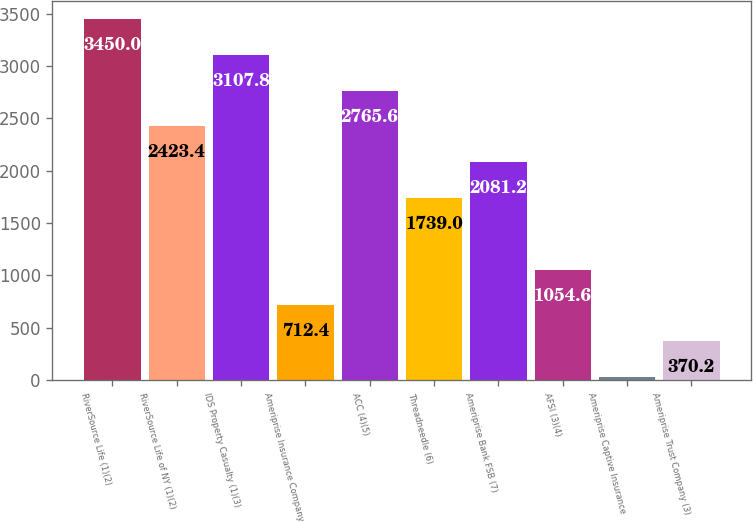<chart> <loc_0><loc_0><loc_500><loc_500><bar_chart><fcel>RiverSource Life (1)(2)<fcel>RiverSource Life of NY (1)(2)<fcel>IDS Property Casualty (1)(3)<fcel>Ameriprise Insurance Company<fcel>ACC (4)(5)<fcel>Threadneedle (6)<fcel>Ameriprise Bank FSB (7)<fcel>AFSI (3)(4)<fcel>Ameriprise Captive Insurance<fcel>Ameriprise Trust Company (3)<nl><fcel>3450<fcel>2423.4<fcel>3107.8<fcel>712.4<fcel>2765.6<fcel>1739<fcel>2081.2<fcel>1054.6<fcel>28<fcel>370.2<nl></chart> 